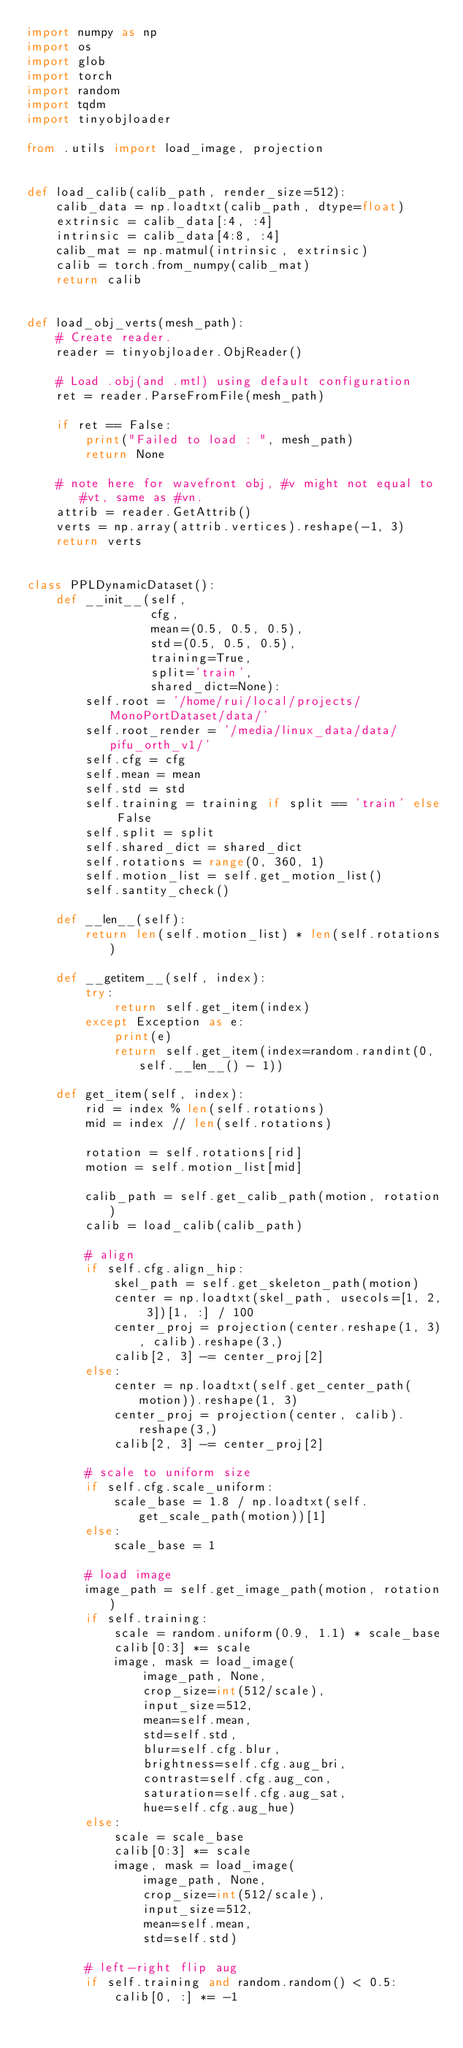<code> <loc_0><loc_0><loc_500><loc_500><_Python_>import numpy as np
import os
import glob
import torch
import random
import tqdm
import tinyobjloader

from .utils import load_image, projection


def load_calib(calib_path, render_size=512):
    calib_data = np.loadtxt(calib_path, dtype=float)
    extrinsic = calib_data[:4, :4]
    intrinsic = calib_data[4:8, :4] 
    calib_mat = np.matmul(intrinsic, extrinsic)
    calib = torch.from_numpy(calib_mat)
    return calib


def load_obj_verts(mesh_path):
    # Create reader.
    reader = tinyobjloader.ObjReader()

    # Load .obj(and .mtl) using default configuration
    ret = reader.ParseFromFile(mesh_path)

    if ret == False:
        print("Failed to load : ", mesh_path)
        return None

    # note here for wavefront obj, #v might not equal to #vt, same as #vn.
    attrib = reader.GetAttrib()
    verts = np.array(attrib.vertices).reshape(-1, 3)
    return verts


class PPLDynamicDataset():
    def __init__(self, 
                 cfg, 
                 mean=(0.5, 0.5, 0.5), 
                 std=(0.5, 0.5, 0.5), 
                 training=True, 
                 split='train',
                 shared_dict=None):
        self.root = '/home/rui/local/projects/MonoPortDataset/data/'
        self.root_render = '/media/linux_data/data/pifu_orth_v1/'
        self.cfg = cfg
        self.mean = mean
        self.std = std
        self.training = training if split == 'train' else False
        self.split = split
        self.shared_dict = shared_dict
        self.rotations = range(0, 360, 1)
        self.motion_list = self.get_motion_list()
        self.santity_check()
        
    def __len__(self):
        return len(self.motion_list) * len(self.rotations)

    def __getitem__(self, index):
        try:
            return self.get_item(index)
        except Exception as e:
            print(e)
            return self.get_item(index=random.randint(0, self.__len__() - 1))

    def get_item(self, index):  
        rid = index % len(self.rotations)
        mid = index // len(self.rotations)

        rotation = self.rotations[rid]
        motion = self.motion_list[mid]

        calib_path = self.get_calib_path(motion, rotation)
        calib = load_calib(calib_path)

        # align        
        if self.cfg.align_hip:
            skel_path = self.get_skeleton_path(motion)
            center = np.loadtxt(skel_path, usecols=[1, 2, 3])[1, :] / 100
            center_proj = projection(center.reshape(1, 3), calib).reshape(3,)
            calib[2, 3] -= center_proj[2]
        else:
            center = np.loadtxt(self.get_center_path(motion)).reshape(1, 3)
            center_proj = projection(center, calib).reshape(3,)
            calib[2, 3] -= center_proj[2]

        # scale to uniform size
        if self.cfg.scale_uniform:
            scale_base = 1.8 / np.loadtxt(self.get_scale_path(motion))[1]
        else:
            scale_base = 1

        # load image
        image_path = self.get_image_path(motion, rotation)
        if self.training:
            scale = random.uniform(0.9, 1.1) * scale_base
            calib[0:3] *= scale
            image, mask = load_image(
                image_path, None,
                crop_size=int(512/scale), 
                input_size=512, 
                mean=self.mean, 
                std=self.std,
                blur=self.cfg.blur,
                brightness=self.cfg.aug_bri, 
                contrast=self.cfg.aug_con, 
                saturation=self.cfg.aug_sat, 
                hue=self.cfg.aug_hue)
        else:
            scale = scale_base
            calib[0:3] *= scale
            image, mask = load_image(
                image_path, None,
                crop_size=int(512/scale), 
                input_size=512, 
                mean=self.mean, 
                std=self.std)

        # left-right flip aug
        if self.training and random.random() < 0.5:
            calib[0, :] *= -1</code> 